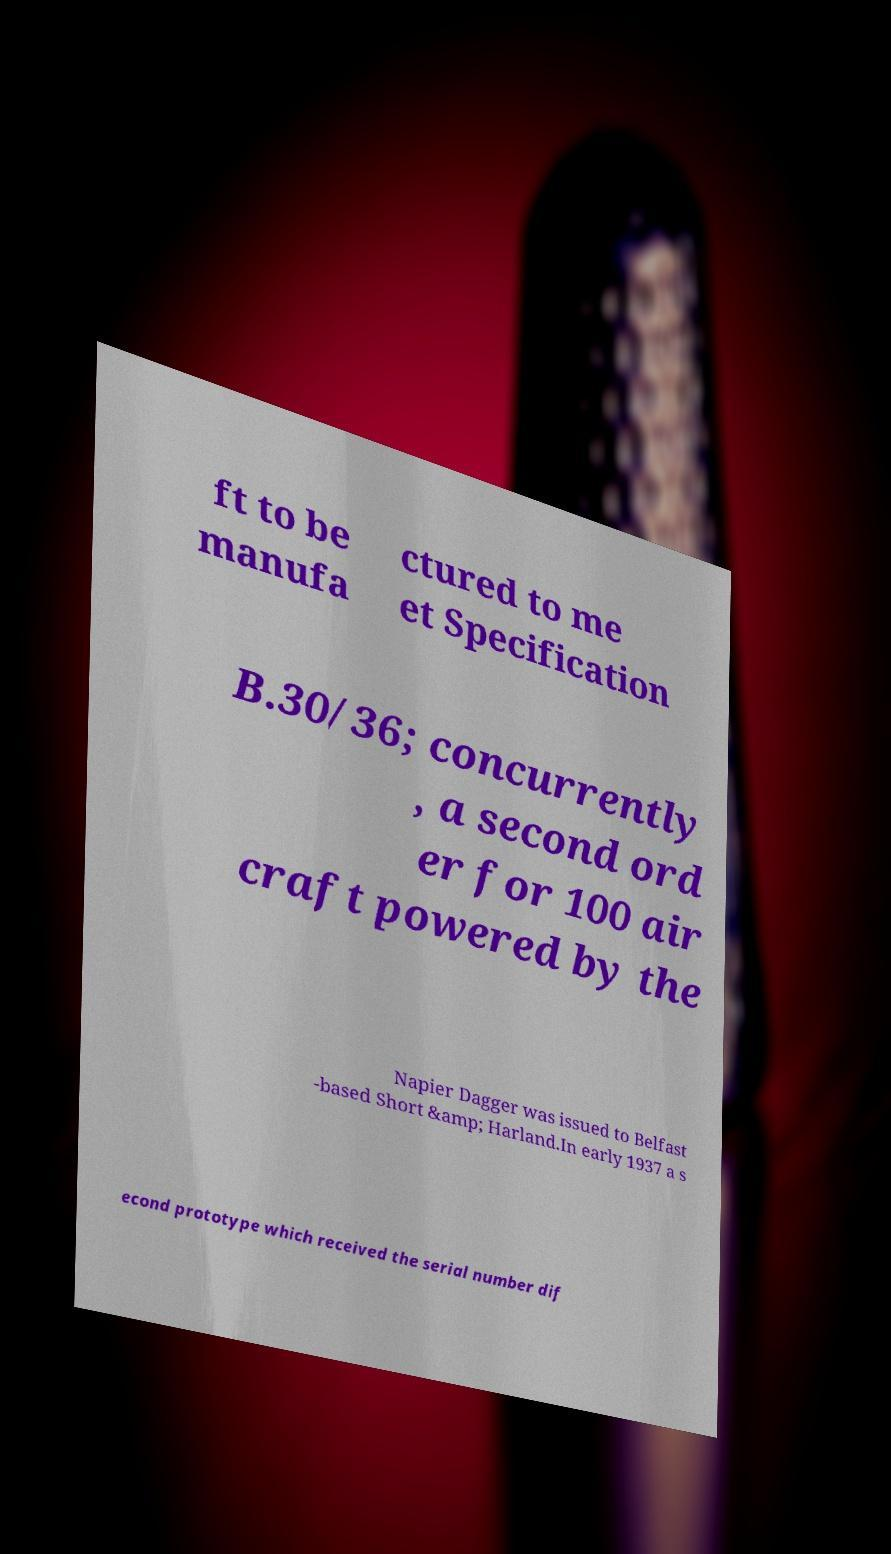For documentation purposes, I need the text within this image transcribed. Could you provide that? ft to be manufa ctured to me et Specification B.30/36; concurrently , a second ord er for 100 air craft powered by the Napier Dagger was issued to Belfast -based Short &amp; Harland.In early 1937 a s econd prototype which received the serial number dif 